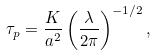<formula> <loc_0><loc_0><loc_500><loc_500>\tau _ { p } = \frac { K } { a ^ { 2 } } \left ( \frac { \lambda } { 2 \pi } \right ) ^ { - 1 / 2 } ,</formula> 